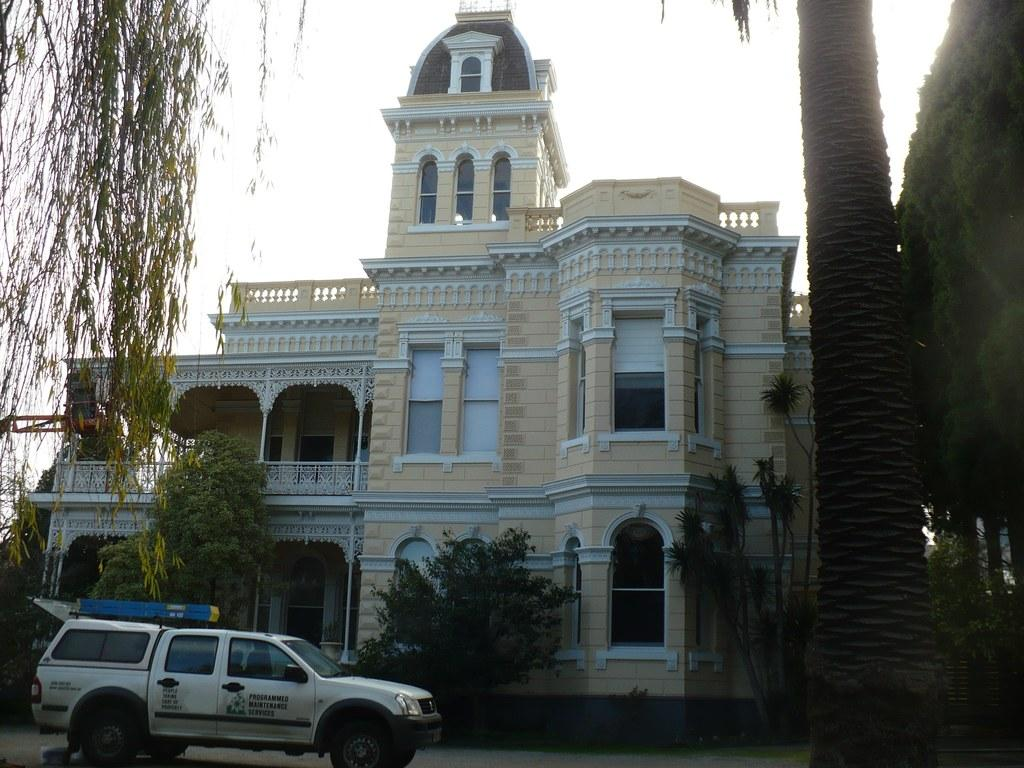What is located on the ground in the image? There is a vehicle on the ground in the image. What type of natural elements can be seen in the image? There are trees in the image. What type of structure is present in the image? There is a building with windows in the image. What is visible in the background of the image? The sky is visible in the background of the image. How many shades of blue can be seen in the foot of the building in the image? There is no mention of a foot or shades of blue in the image; it features a vehicle, trees, a building, and the sky. 